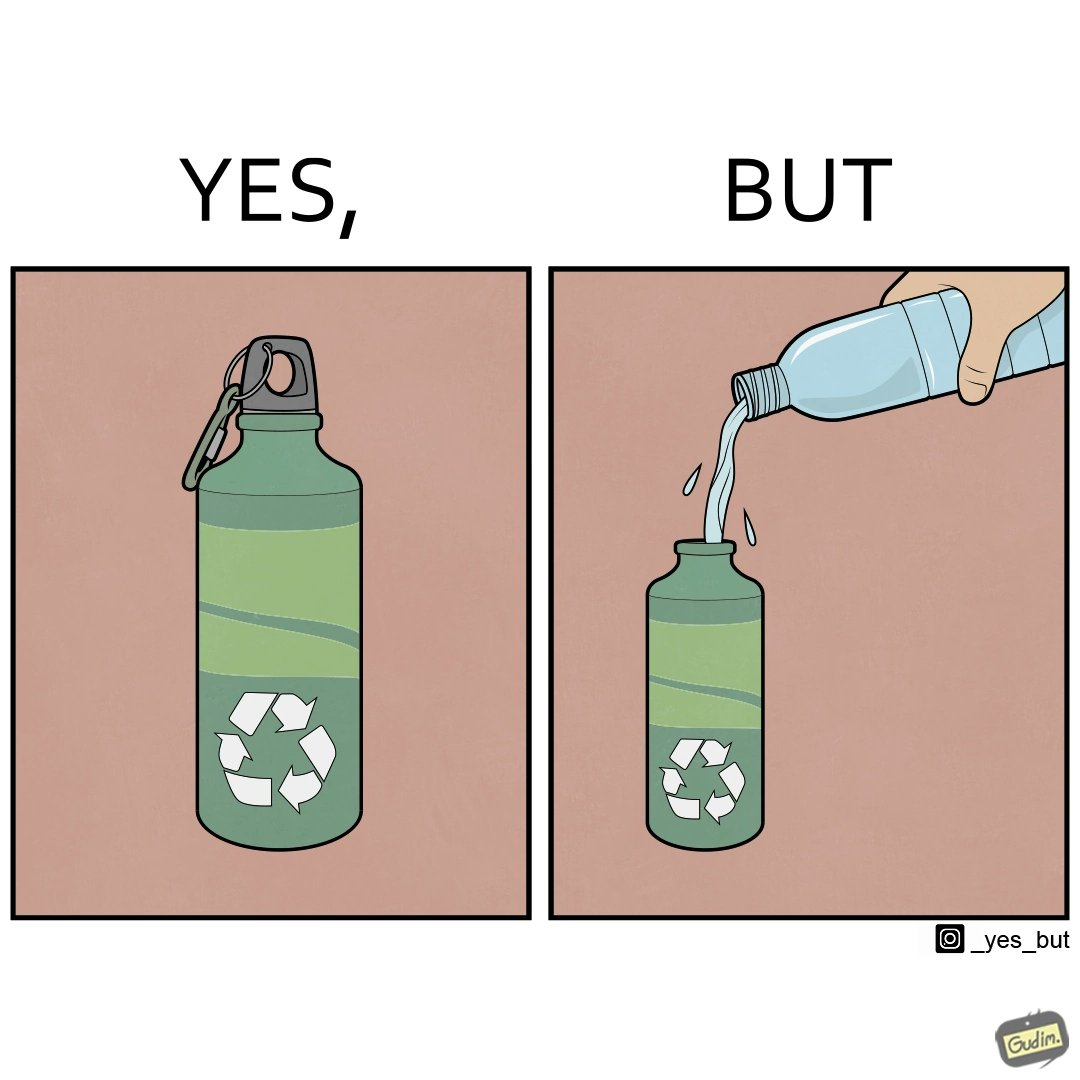What is shown in the left half versus the right half of this image? In the left part of the image: It is a metallic water bottle In the right part of the image: A metallic water bottle being filled by a plastic water bottle 